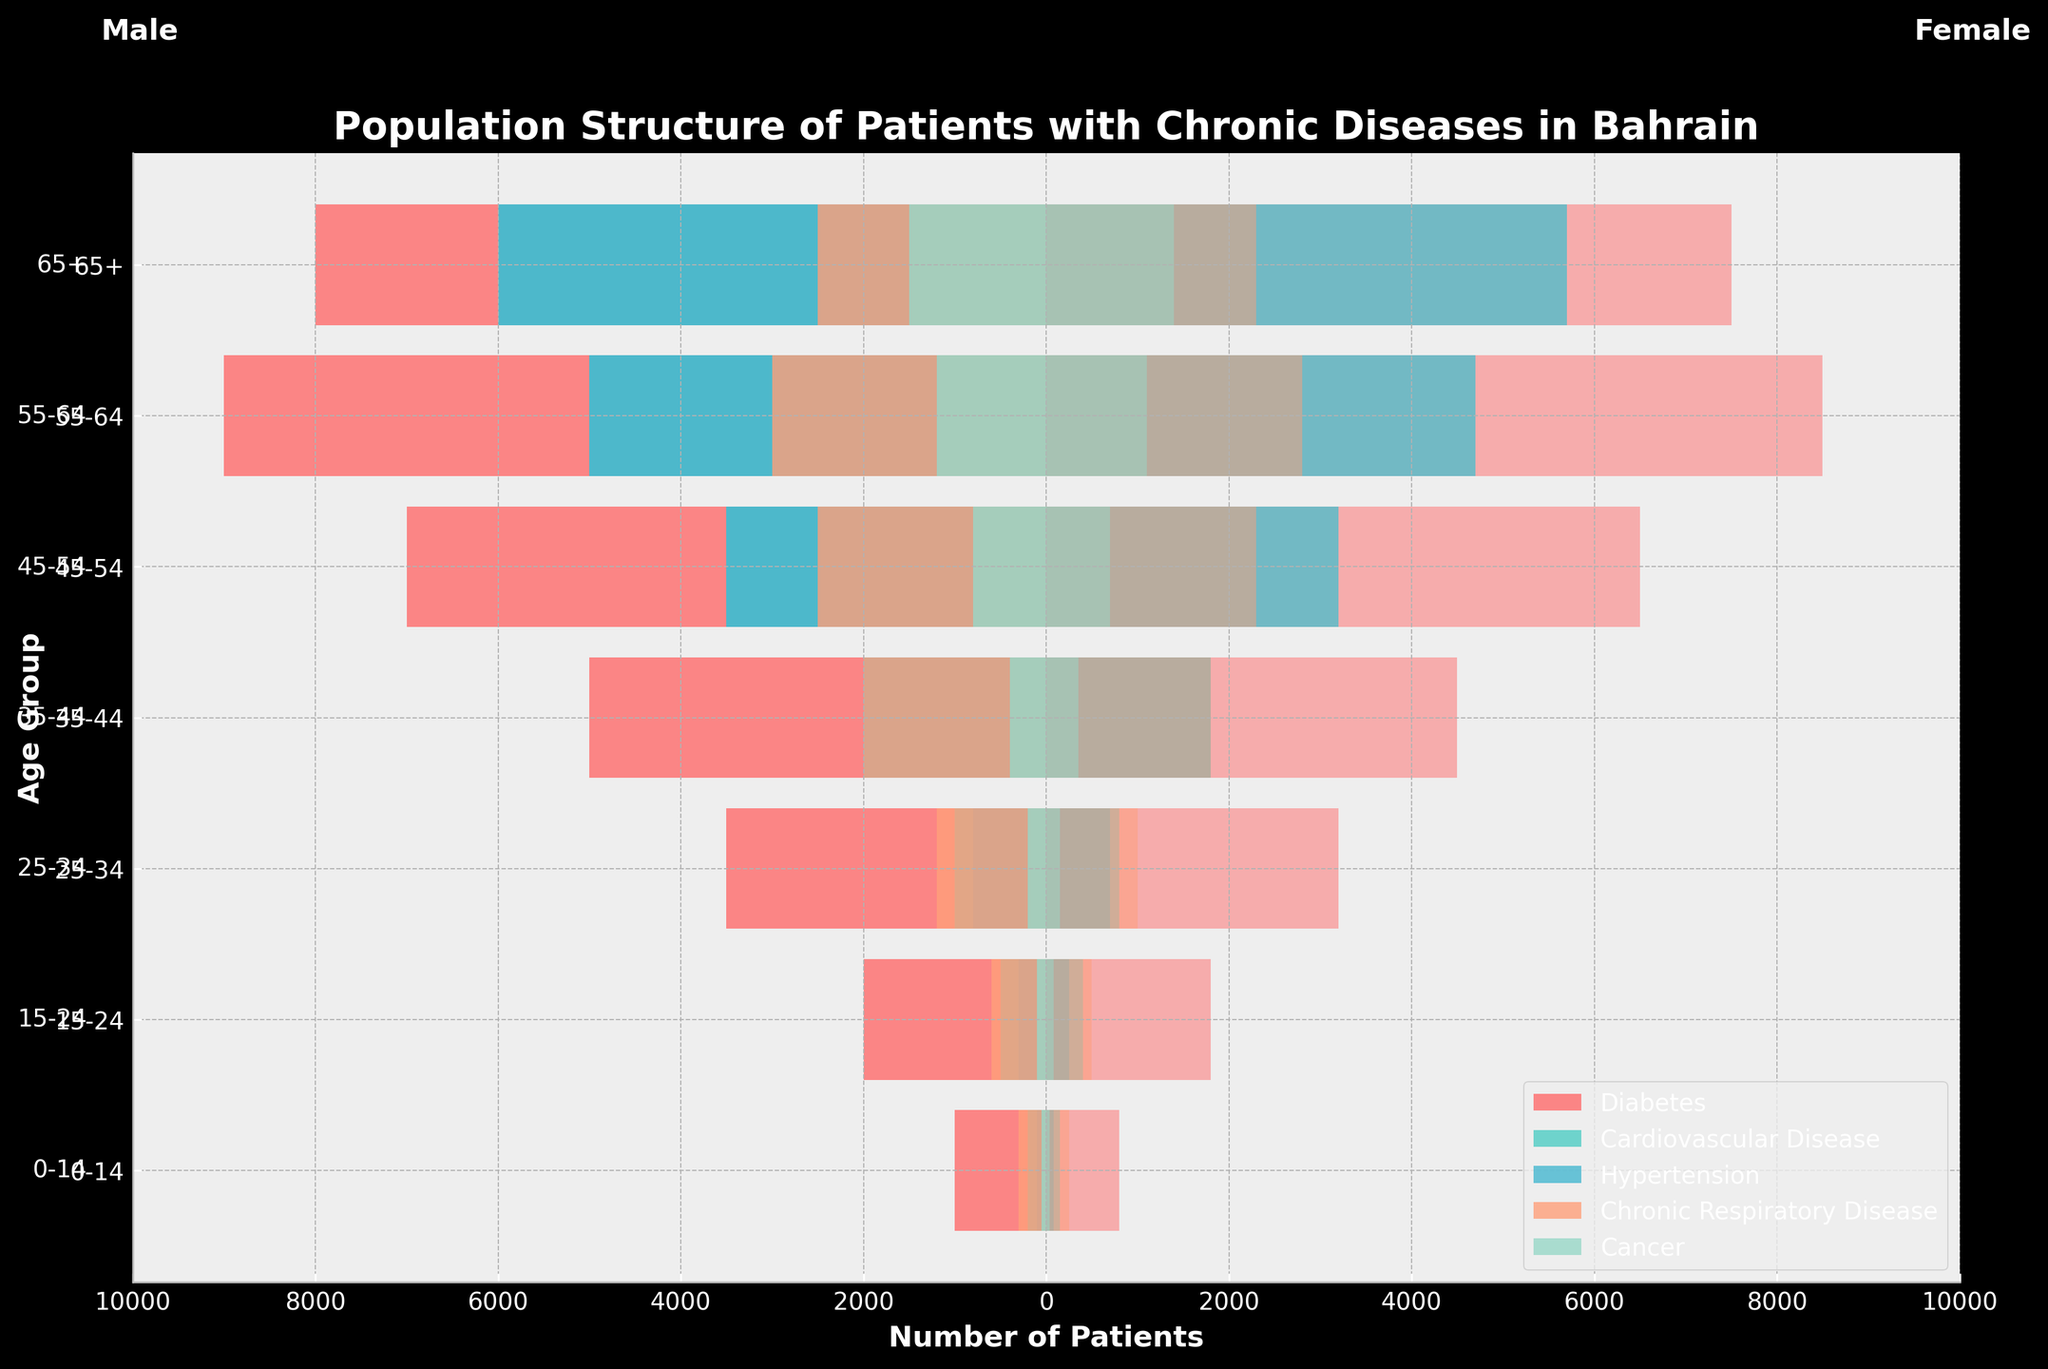What's the title of the figure? The title is located at the top of the figure. By reading it, we can understand that the visualization is about "Population Structure of Patients with Chronic Diseases in Bahrain."
Answer: Population Structure of Patients with Chronic Diseases in Bahrain Which age group has the highest number of female patients with diabetes? By observing the positive part of the bars for diabetes, it's clear which age group has the longest bar on the female side. The 55-64 age group has the highest number of female patients with diabetes.
Answer: 55-64 How many male patients aged 45-54 suffer from hypertension? Reference the negative part of the bars for hypertension (age group 45-54). The bar representing males in this age group is -3500, signaling that there are 3500 male patients.
Answer: 3500 Compare the number of female patients aged 35-44 with cardiovascular disease to those with chronic respiratory disease. Which is higher? Check the positive part of the bars for both diseases in the 35-44 age group. The bar for cardiovascular disease is slightly shorter than the bar for chronic respiratory disease, meaning the number of female patients is higher in the latter.
Answer: Chronic Respiratory Disease What is the total number of female patients aged 65+ across all chronic disease categories? Sum up the positive parts of the bars for each disease in the 65+ age group: 7500 (Diabetes) + 5700 (Cardiovascular Disease) + 5700 (Hypertension) + 2300 (Chronic Respiratory Disease) + 1400 (Cancer) = 22600.
Answer: 22600 In which age group is the gender disparity for diabetes patients the greatest, and by how much? Calculate the absolute difference between the male and female bars for diabetes across age groups. The ages 55-64 show the highest disparity: 9000 (males) - 8500 (females) = 500.
Answer: 55-64; 500 Which disease category shows the least variance between male and female patients aged 25-34? Examine the bars for all chronic diseases in the 25-34 age group, focusing on the smallest gap between male and female values. Hypertension and Cancer show a relatively minor difference, but Cancer has the smallest difference at 150.
Answer: Cancer Identify the two age groups where the number of male and female cancer patients is equal. Look for the pairs of bars (one positive and one negative) that are of equal length in the cancer category. The age groups 15-24 and 35-44 display equal numbers for males and females.
Answer: 15-24, 35-44 Which disease category has the maximum number of patients (both genders combined) in the age group 55-64? Sum male and female patients for each disease in the 55-64 age group: Hypertension has 5000 (male) + 4700 (female) = 9700, which is the highest combined number.
Answer: Hypertension For patients with chronic respiratory disease, what is the percentage increase in female patients from age group 15-24 to age group 25-34? Calculate the percentage increase: ((1000 - 500) / 500) * 100 = 100%.
Answer: 100% 